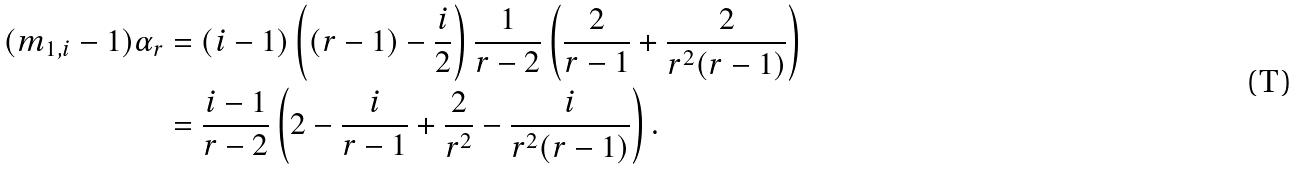Convert formula to latex. <formula><loc_0><loc_0><loc_500><loc_500>( m _ { 1 , i } - 1 ) \alpha _ { r } & = ( i - 1 ) \left ( ( r - 1 ) - \frac { i } { 2 } \right ) \frac { 1 } { r - 2 } \left ( \frac { 2 } { r - 1 } + \frac { 2 } { r ^ { 2 } ( r - 1 ) } \right ) \\ & = \frac { i - 1 } { r - 2 } \left ( 2 - \frac { i } { r - 1 } + \frac { 2 } { r ^ { 2 } } - \frac { i } { r ^ { 2 } ( r - 1 ) } \right ) .</formula> 